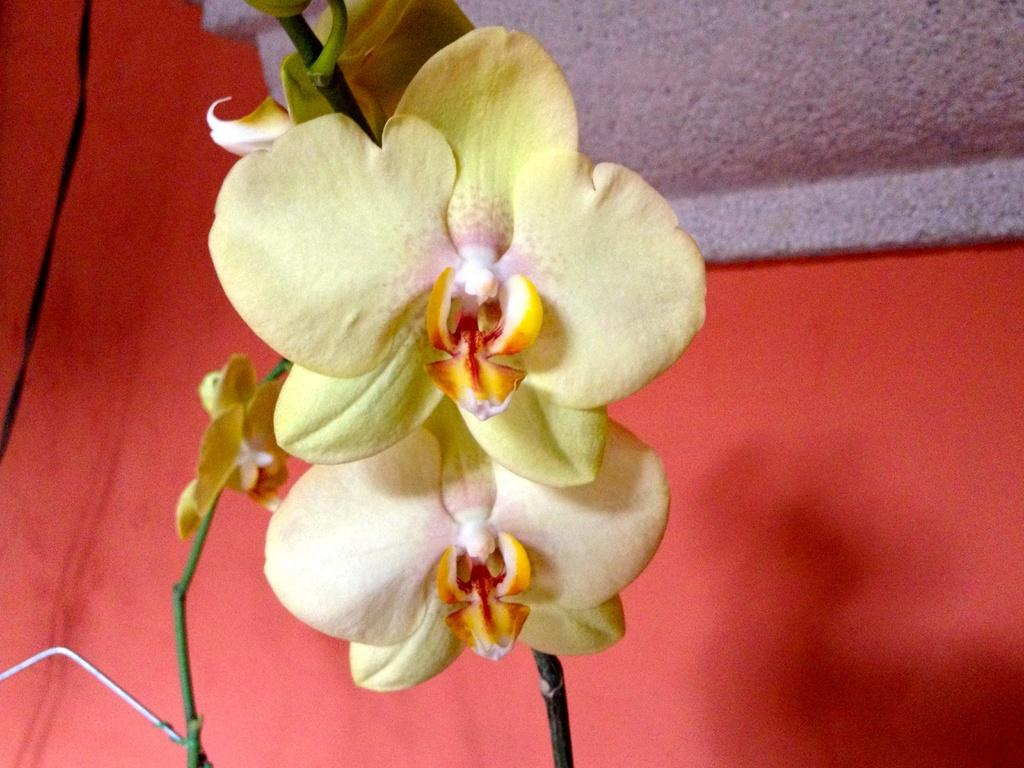What is the main subject in the foreground of the image? There is a flower in the foreground of the image. What can be seen in the background of the image? There is a wall in the background of the image. How many men are standing next to the cattle in the image? There are no men or cattle present in the image; it only features a flower in the foreground and a wall in the background. 